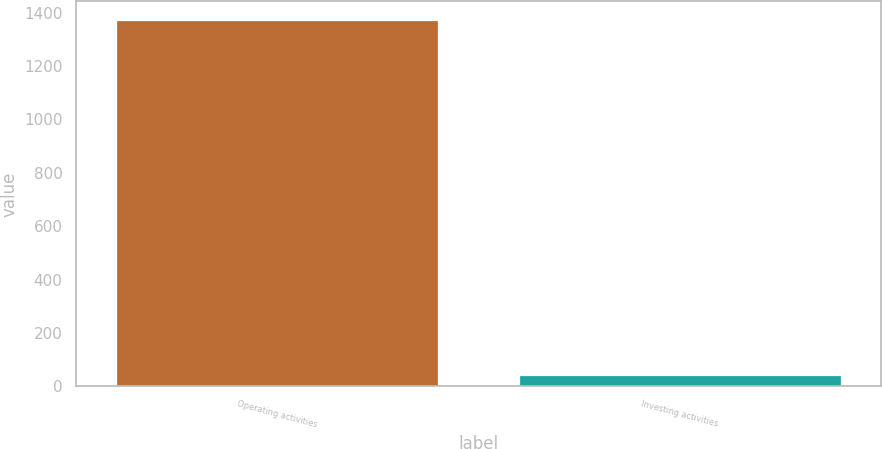<chart> <loc_0><loc_0><loc_500><loc_500><bar_chart><fcel>Operating activities<fcel>Investing activities<nl><fcel>1373<fcel>44<nl></chart> 